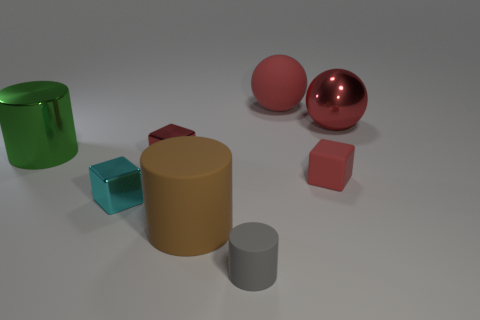How would you describe the surface textures? In this image, there is a distinct contrast between textures. The large cylinder and the sphere have reflective, glossy textures that indicate a metal-like material, resulting in clear highlights and reflections. On the other hand, the small cylinder, cube, and rectangular prism display matte surfaces, which absorb more light and therefore do not exhibit strong reflections or highlights. These textural differences add to the visual interest and depth of the image. 